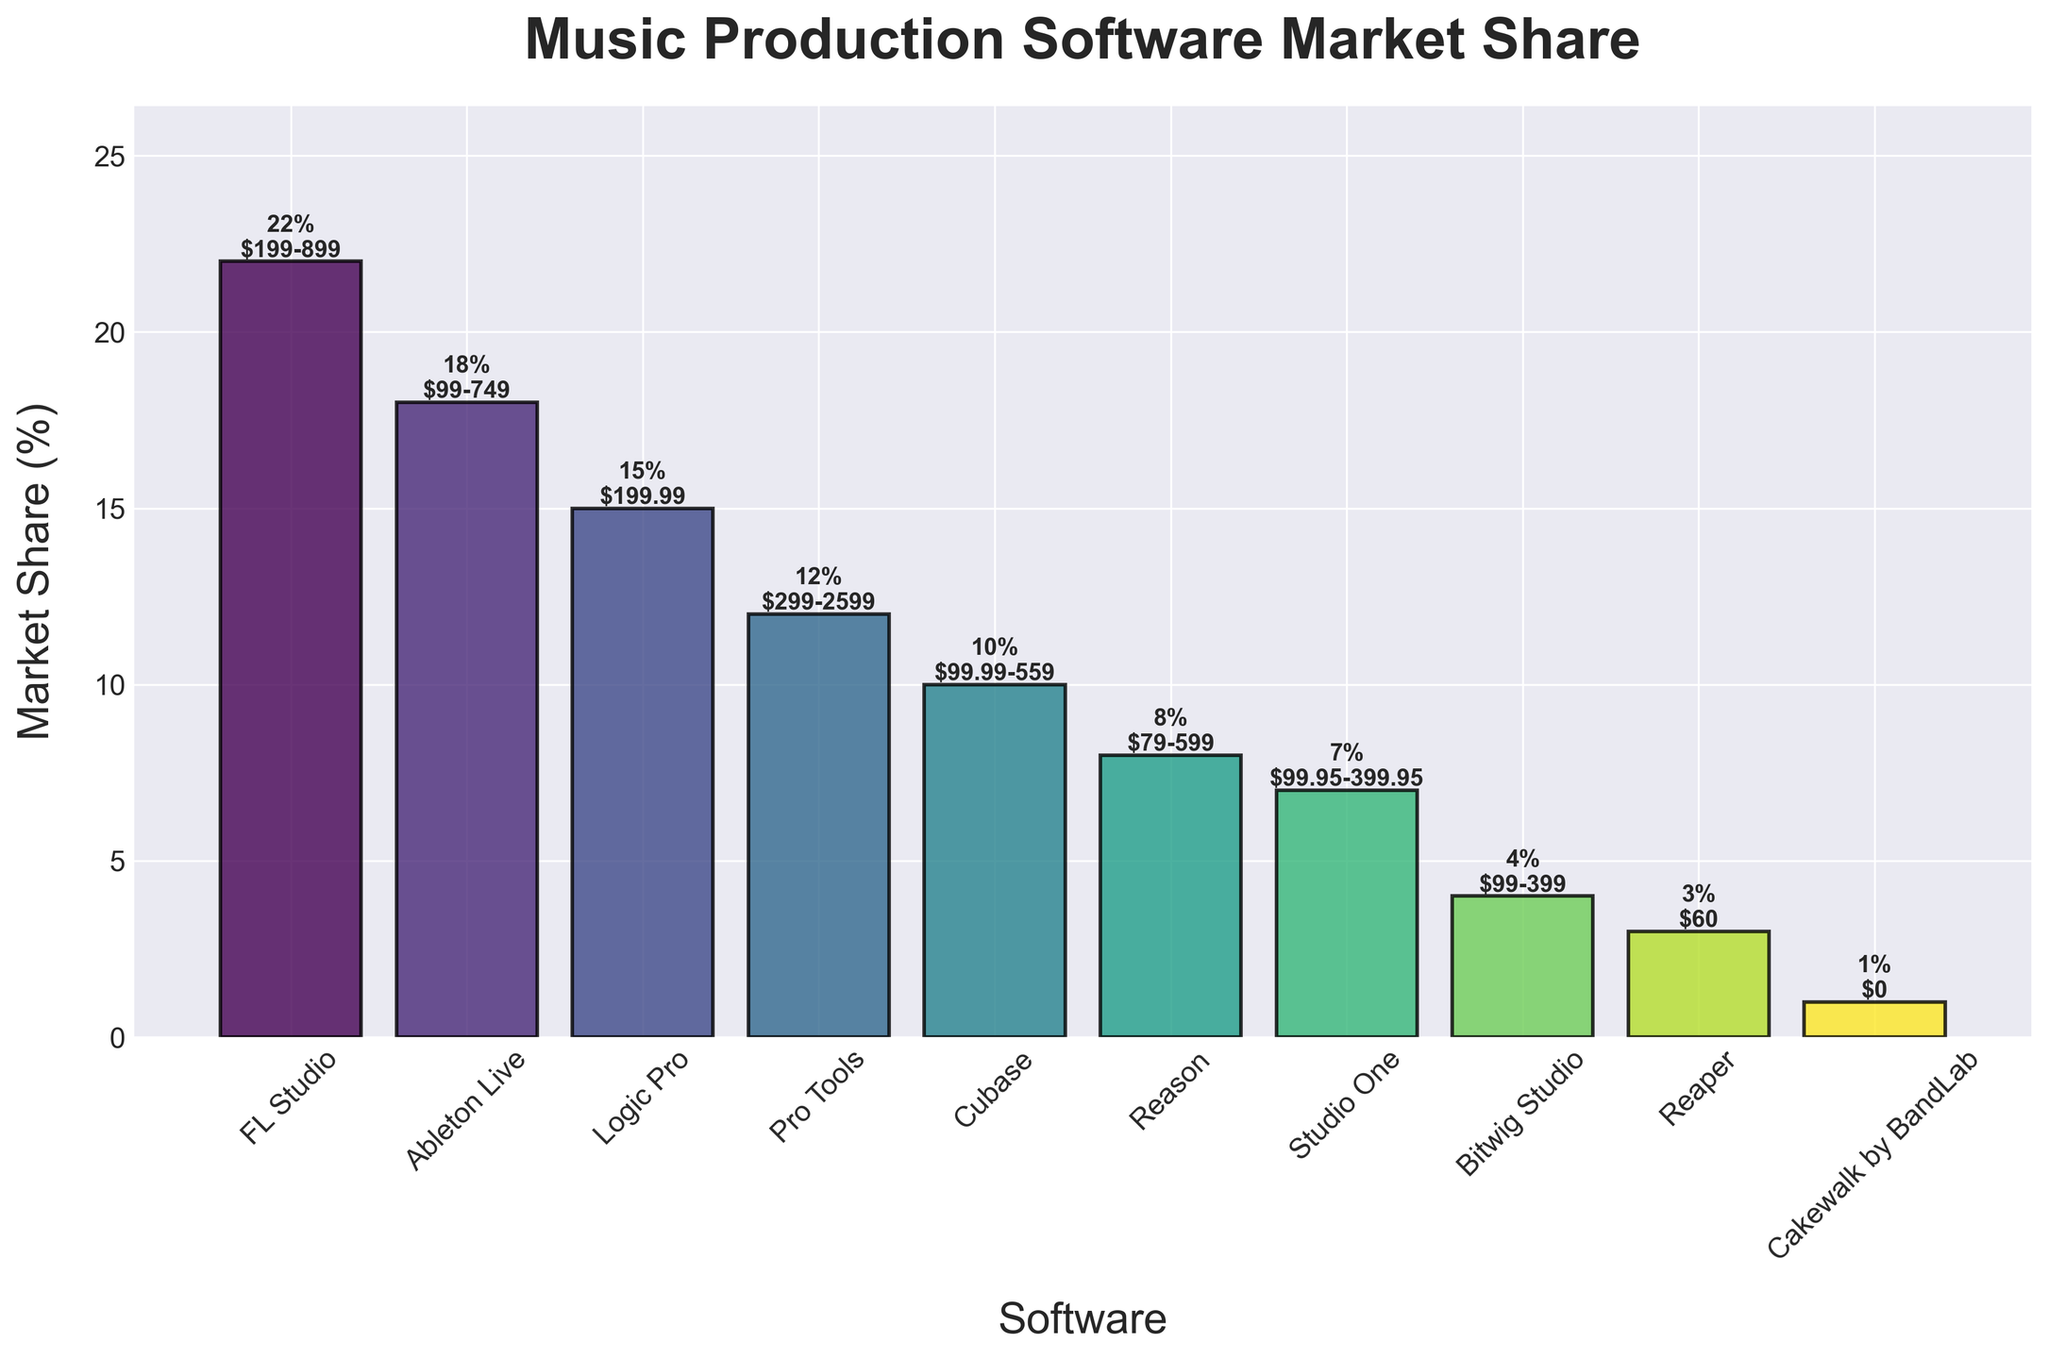Which software has the highest market share? By referring to the bar chart, the software with the tallest bar represents the software with the highest market share. In this case, FL Studio has the tallest bar.
Answer: FL Studio How much higher is the market share of Logic Pro compared to Studio One? To determine this, find the market share percentages of Logic Pro and Studio One from the chart. Logic Pro has 15% and Studio One has 7%. The difference is calculated as 15% - 7% = 8%.
Answer: 8% Which software is in the lowest price range and what is its market share? Identify the software with the lowest price range by checking the labels under the bars. Cakewalk by BandLab is priced $0 and has the shortest bar with a market share of 1%.
Answer: Cakewalk by BandLab, 1% Compare the price range of Pro Tools and Bitwig Studio. Which one has the higher upper limit? Refer to the price range annotations on top of the bars for both Pro Tools and Bitwig Studio. Pro Tools has a price range of $299-$2599, while Bitwig Studio is $99-$399. Pro Tools has the higher upper limit.
Answer: Pro Tools What is the combined market share of the three least popular software? Identify the three least popular software by finding the shortest bars. Reaper (3%), Bitwig Studio (4%), and Cakewalk by BandLab (1%). Add their market shares: 3% + 4% + 1% = 8%.
Answer: 8% Which software has a market share close to its minimum price range of less than $100? Look for the software whose starting price range is less than $100 and has a market share close to that amount. Reason fits this criterion with a market share of 8% and a price range starting at $79.
Answer: Reason What proportion of the market share is occupied by software with an upper price limit above $500? Examine the software price ranges to find those exceeding $500: FL Studio, Pro Tools, Cubase, and Reason. Sum their market shares: FL Studio (22%), Pro Tools (12%), Cubase (10%), Reason (8%). The total is 22% + 12% + 10% + 8% = 52%.
Answer: 52% Which software is in the second highest price range and what is the range? Identify the software with the second highest upper limit by checking the price range annotations. Pro Tools has the highest at $2599, and the second highest is FL Studio at $899.
Answer: FL Studio, $199-$899 